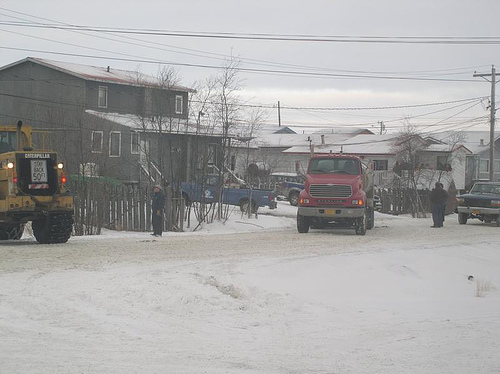<image>
Is the sky behind the building? Yes. From this viewpoint, the sky is positioned behind the building, with the building partially or fully occluding the sky. 